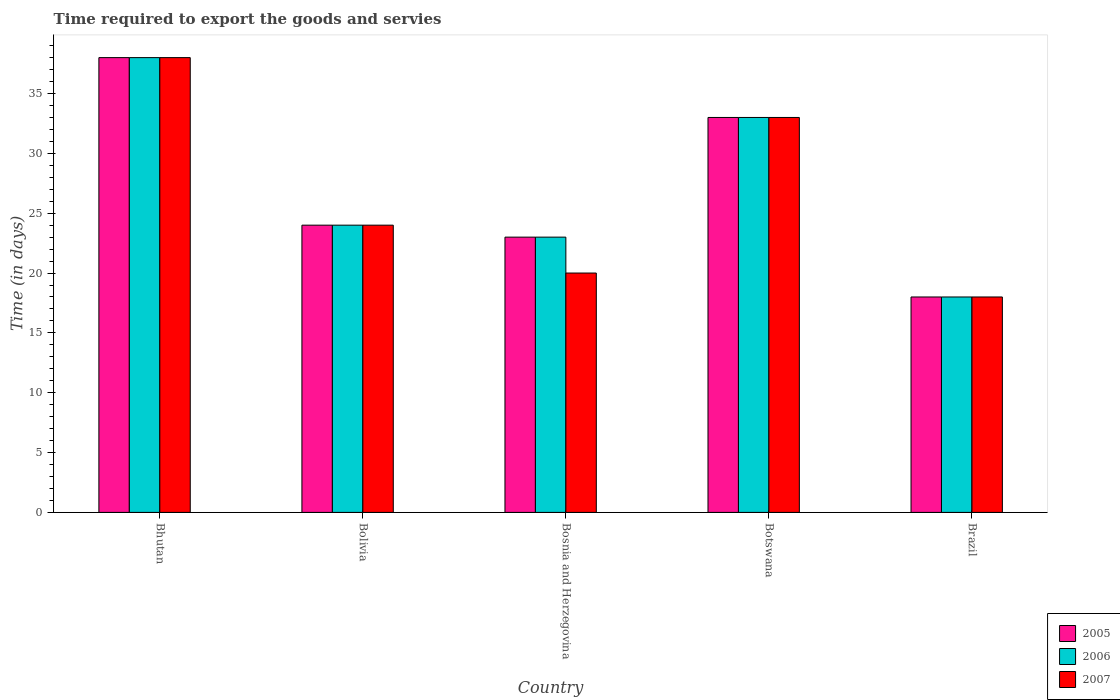What is the label of the 2nd group of bars from the left?
Make the answer very short. Bolivia. In which country was the number of days required to export the goods and services in 2005 maximum?
Ensure brevity in your answer.  Bhutan. In which country was the number of days required to export the goods and services in 2005 minimum?
Your response must be concise. Brazil. What is the total number of days required to export the goods and services in 2007 in the graph?
Ensure brevity in your answer.  133. What is the difference between the number of days required to export the goods and services in 2007 in Botswana and that in Brazil?
Your answer should be very brief. 15. What is the difference between the number of days required to export the goods and services in 2007 in Bosnia and Herzegovina and the number of days required to export the goods and services in 2006 in Brazil?
Offer a very short reply. 2. What is the average number of days required to export the goods and services in 2006 per country?
Ensure brevity in your answer.  27.2. What is the ratio of the number of days required to export the goods and services in 2005 in Bosnia and Herzegovina to that in Brazil?
Make the answer very short. 1.28. What is the difference between the highest and the second highest number of days required to export the goods and services in 2007?
Your answer should be very brief. -9. In how many countries, is the number of days required to export the goods and services in 2005 greater than the average number of days required to export the goods and services in 2005 taken over all countries?
Provide a short and direct response. 2. Is the sum of the number of days required to export the goods and services in 2005 in Bhutan and Botswana greater than the maximum number of days required to export the goods and services in 2006 across all countries?
Offer a terse response. Yes. What does the 1st bar from the left in Botswana represents?
Give a very brief answer. 2005. Is it the case that in every country, the sum of the number of days required to export the goods and services in 2006 and number of days required to export the goods and services in 2005 is greater than the number of days required to export the goods and services in 2007?
Your response must be concise. Yes. Are all the bars in the graph horizontal?
Your answer should be very brief. No. How many countries are there in the graph?
Keep it short and to the point. 5. What is the difference between two consecutive major ticks on the Y-axis?
Ensure brevity in your answer.  5. Are the values on the major ticks of Y-axis written in scientific E-notation?
Offer a very short reply. No. Does the graph contain any zero values?
Provide a succinct answer. No. Does the graph contain grids?
Your response must be concise. No. Where does the legend appear in the graph?
Give a very brief answer. Bottom right. How are the legend labels stacked?
Offer a terse response. Vertical. What is the title of the graph?
Your answer should be compact. Time required to export the goods and servies. What is the label or title of the Y-axis?
Keep it short and to the point. Time (in days). What is the Time (in days) of 2006 in Bhutan?
Your answer should be compact. 38. What is the Time (in days) of 2006 in Bolivia?
Provide a succinct answer. 24. What is the Time (in days) in 2006 in Bosnia and Herzegovina?
Your answer should be compact. 23. What is the Time (in days) of 2005 in Botswana?
Ensure brevity in your answer.  33. What is the Time (in days) of 2006 in Botswana?
Your response must be concise. 33. What is the Time (in days) in 2007 in Botswana?
Your answer should be very brief. 33. What is the Time (in days) in 2005 in Brazil?
Offer a very short reply. 18. What is the Time (in days) of 2006 in Brazil?
Offer a very short reply. 18. What is the Time (in days) in 2007 in Brazil?
Give a very brief answer. 18. Across all countries, what is the maximum Time (in days) of 2007?
Provide a succinct answer. 38. Across all countries, what is the minimum Time (in days) in 2005?
Provide a short and direct response. 18. Across all countries, what is the minimum Time (in days) in 2006?
Keep it short and to the point. 18. What is the total Time (in days) in 2005 in the graph?
Give a very brief answer. 136. What is the total Time (in days) in 2006 in the graph?
Keep it short and to the point. 136. What is the total Time (in days) of 2007 in the graph?
Ensure brevity in your answer.  133. What is the difference between the Time (in days) in 2006 in Bhutan and that in Bolivia?
Offer a terse response. 14. What is the difference between the Time (in days) in 2007 in Bhutan and that in Bolivia?
Ensure brevity in your answer.  14. What is the difference between the Time (in days) in 2005 in Bhutan and that in Bosnia and Herzegovina?
Ensure brevity in your answer.  15. What is the difference between the Time (in days) of 2006 in Bhutan and that in Bosnia and Herzegovina?
Your response must be concise. 15. What is the difference between the Time (in days) of 2005 in Bhutan and that in Botswana?
Ensure brevity in your answer.  5. What is the difference between the Time (in days) of 2005 in Bhutan and that in Brazil?
Ensure brevity in your answer.  20. What is the difference between the Time (in days) in 2006 in Bhutan and that in Brazil?
Provide a succinct answer. 20. What is the difference between the Time (in days) of 2005 in Bolivia and that in Botswana?
Provide a succinct answer. -9. What is the difference between the Time (in days) of 2007 in Bolivia and that in Botswana?
Keep it short and to the point. -9. What is the difference between the Time (in days) in 2006 in Bolivia and that in Brazil?
Offer a very short reply. 6. What is the difference between the Time (in days) in 2005 in Bosnia and Herzegovina and that in Botswana?
Ensure brevity in your answer.  -10. What is the difference between the Time (in days) in 2005 in Bosnia and Herzegovina and that in Brazil?
Offer a terse response. 5. What is the difference between the Time (in days) of 2006 in Bosnia and Herzegovina and that in Brazil?
Provide a succinct answer. 5. What is the difference between the Time (in days) of 2005 in Botswana and that in Brazil?
Your answer should be very brief. 15. What is the difference between the Time (in days) of 2006 in Botswana and that in Brazil?
Your answer should be very brief. 15. What is the difference between the Time (in days) of 2005 in Bhutan and the Time (in days) of 2007 in Bolivia?
Provide a short and direct response. 14. What is the difference between the Time (in days) in 2006 in Bhutan and the Time (in days) in 2007 in Bolivia?
Your answer should be very brief. 14. What is the difference between the Time (in days) in 2005 in Bhutan and the Time (in days) in 2006 in Bosnia and Herzegovina?
Your answer should be very brief. 15. What is the difference between the Time (in days) of 2006 in Bhutan and the Time (in days) of 2007 in Bosnia and Herzegovina?
Your answer should be very brief. 18. What is the difference between the Time (in days) of 2005 in Bhutan and the Time (in days) of 2007 in Botswana?
Give a very brief answer. 5. What is the difference between the Time (in days) in 2006 in Bhutan and the Time (in days) in 2007 in Botswana?
Offer a very short reply. 5. What is the difference between the Time (in days) in 2005 in Bhutan and the Time (in days) in 2006 in Brazil?
Keep it short and to the point. 20. What is the difference between the Time (in days) in 2005 in Bhutan and the Time (in days) in 2007 in Brazil?
Offer a terse response. 20. What is the difference between the Time (in days) of 2006 in Bhutan and the Time (in days) of 2007 in Brazil?
Make the answer very short. 20. What is the difference between the Time (in days) of 2005 in Bolivia and the Time (in days) of 2006 in Bosnia and Herzegovina?
Provide a short and direct response. 1. What is the difference between the Time (in days) in 2005 in Bolivia and the Time (in days) in 2006 in Botswana?
Offer a very short reply. -9. What is the difference between the Time (in days) of 2005 in Bolivia and the Time (in days) of 2007 in Botswana?
Give a very brief answer. -9. What is the difference between the Time (in days) of 2006 in Bolivia and the Time (in days) of 2007 in Botswana?
Make the answer very short. -9. What is the difference between the Time (in days) in 2005 in Bolivia and the Time (in days) in 2006 in Brazil?
Provide a short and direct response. 6. What is the difference between the Time (in days) of 2006 in Bolivia and the Time (in days) of 2007 in Brazil?
Your answer should be very brief. 6. What is the difference between the Time (in days) of 2006 in Bosnia and Herzegovina and the Time (in days) of 2007 in Botswana?
Offer a very short reply. -10. What is the difference between the Time (in days) in 2005 in Bosnia and Herzegovina and the Time (in days) in 2006 in Brazil?
Give a very brief answer. 5. What is the difference between the Time (in days) in 2006 in Bosnia and Herzegovina and the Time (in days) in 2007 in Brazil?
Give a very brief answer. 5. What is the difference between the Time (in days) in 2005 in Botswana and the Time (in days) in 2006 in Brazil?
Your answer should be compact. 15. What is the difference between the Time (in days) of 2006 in Botswana and the Time (in days) of 2007 in Brazil?
Your answer should be compact. 15. What is the average Time (in days) in 2005 per country?
Your response must be concise. 27.2. What is the average Time (in days) in 2006 per country?
Keep it short and to the point. 27.2. What is the average Time (in days) of 2007 per country?
Keep it short and to the point. 26.6. What is the difference between the Time (in days) of 2006 and Time (in days) of 2007 in Bhutan?
Make the answer very short. 0. What is the difference between the Time (in days) in 2006 and Time (in days) in 2007 in Bolivia?
Offer a very short reply. 0. What is the difference between the Time (in days) in 2005 and Time (in days) in 2006 in Bosnia and Herzegovina?
Your answer should be compact. 0. What is the difference between the Time (in days) of 2005 and Time (in days) of 2007 in Botswana?
Offer a terse response. 0. What is the difference between the Time (in days) in 2005 and Time (in days) in 2007 in Brazil?
Your answer should be very brief. 0. What is the difference between the Time (in days) of 2006 and Time (in days) of 2007 in Brazil?
Provide a succinct answer. 0. What is the ratio of the Time (in days) in 2005 in Bhutan to that in Bolivia?
Keep it short and to the point. 1.58. What is the ratio of the Time (in days) of 2006 in Bhutan to that in Bolivia?
Provide a succinct answer. 1.58. What is the ratio of the Time (in days) in 2007 in Bhutan to that in Bolivia?
Give a very brief answer. 1.58. What is the ratio of the Time (in days) in 2005 in Bhutan to that in Bosnia and Herzegovina?
Your response must be concise. 1.65. What is the ratio of the Time (in days) of 2006 in Bhutan to that in Bosnia and Herzegovina?
Your answer should be very brief. 1.65. What is the ratio of the Time (in days) in 2007 in Bhutan to that in Bosnia and Herzegovina?
Your answer should be very brief. 1.9. What is the ratio of the Time (in days) of 2005 in Bhutan to that in Botswana?
Provide a succinct answer. 1.15. What is the ratio of the Time (in days) of 2006 in Bhutan to that in Botswana?
Give a very brief answer. 1.15. What is the ratio of the Time (in days) in 2007 in Bhutan to that in Botswana?
Keep it short and to the point. 1.15. What is the ratio of the Time (in days) of 2005 in Bhutan to that in Brazil?
Provide a succinct answer. 2.11. What is the ratio of the Time (in days) of 2006 in Bhutan to that in Brazil?
Your answer should be very brief. 2.11. What is the ratio of the Time (in days) in 2007 in Bhutan to that in Brazil?
Keep it short and to the point. 2.11. What is the ratio of the Time (in days) in 2005 in Bolivia to that in Bosnia and Herzegovina?
Provide a succinct answer. 1.04. What is the ratio of the Time (in days) of 2006 in Bolivia to that in Bosnia and Herzegovina?
Offer a very short reply. 1.04. What is the ratio of the Time (in days) in 2007 in Bolivia to that in Bosnia and Herzegovina?
Ensure brevity in your answer.  1.2. What is the ratio of the Time (in days) of 2005 in Bolivia to that in Botswana?
Provide a short and direct response. 0.73. What is the ratio of the Time (in days) of 2006 in Bolivia to that in Botswana?
Your response must be concise. 0.73. What is the ratio of the Time (in days) of 2007 in Bolivia to that in Botswana?
Offer a terse response. 0.73. What is the ratio of the Time (in days) of 2005 in Bolivia to that in Brazil?
Make the answer very short. 1.33. What is the ratio of the Time (in days) of 2006 in Bolivia to that in Brazil?
Ensure brevity in your answer.  1.33. What is the ratio of the Time (in days) in 2005 in Bosnia and Herzegovina to that in Botswana?
Your answer should be compact. 0.7. What is the ratio of the Time (in days) in 2006 in Bosnia and Herzegovina to that in Botswana?
Your response must be concise. 0.7. What is the ratio of the Time (in days) in 2007 in Bosnia and Herzegovina to that in Botswana?
Your answer should be compact. 0.61. What is the ratio of the Time (in days) of 2005 in Bosnia and Herzegovina to that in Brazil?
Make the answer very short. 1.28. What is the ratio of the Time (in days) of 2006 in Bosnia and Herzegovina to that in Brazil?
Keep it short and to the point. 1.28. What is the ratio of the Time (in days) in 2007 in Bosnia and Herzegovina to that in Brazil?
Provide a short and direct response. 1.11. What is the ratio of the Time (in days) in 2005 in Botswana to that in Brazil?
Your answer should be compact. 1.83. What is the ratio of the Time (in days) of 2006 in Botswana to that in Brazil?
Your answer should be very brief. 1.83. What is the ratio of the Time (in days) of 2007 in Botswana to that in Brazil?
Keep it short and to the point. 1.83. What is the difference between the highest and the second highest Time (in days) in 2007?
Offer a terse response. 5. 